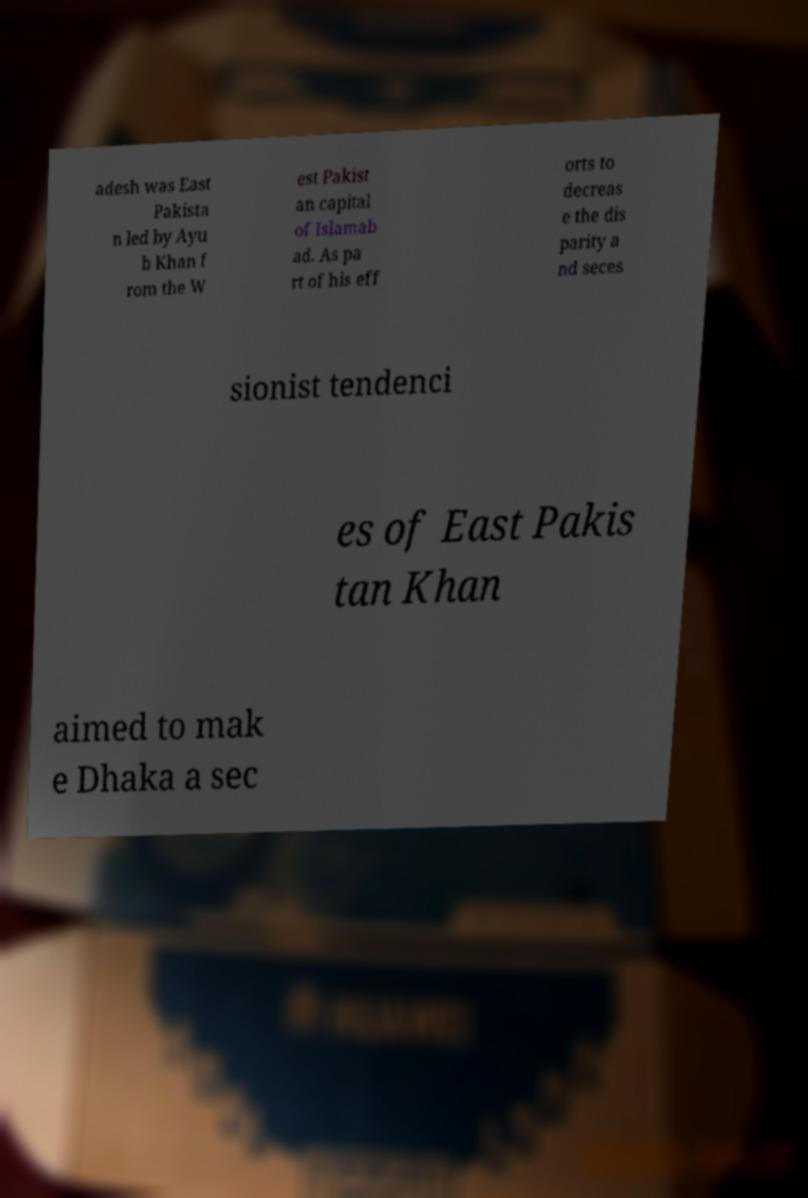Could you assist in decoding the text presented in this image and type it out clearly? adesh was East Pakista n led by Ayu b Khan f rom the W est Pakist an capital of Islamab ad. As pa rt of his eff orts to decreas e the dis parity a nd seces sionist tendenci es of East Pakis tan Khan aimed to mak e Dhaka a sec 